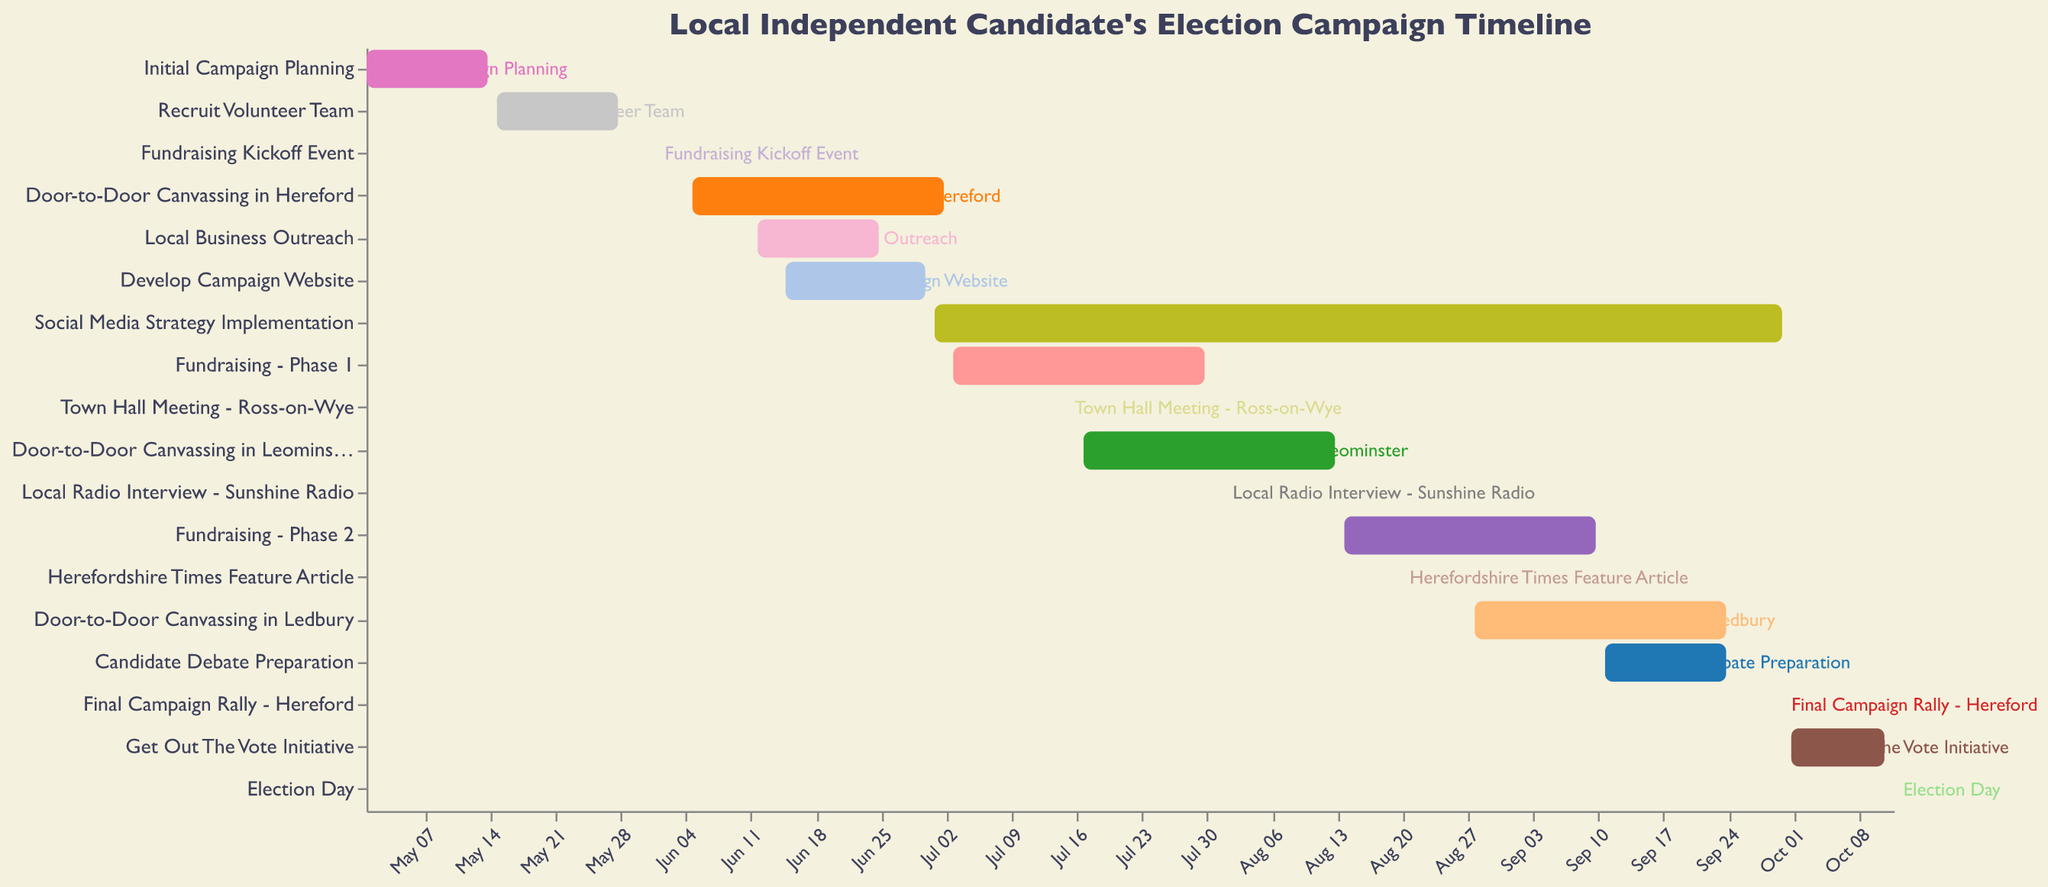What is the title of the Gantt Chart? The title is displayed at the top of the chart and reads "Local Independent Candidate's Election Campaign Timeline."
Answer: Local Independent Candidate's Election Campaign Timeline When does the "Initial Campaign Planning" phase begin and end? The phase is represented by a horizontal bar on the Gantt chart, starting on May 1 and ending on May 14.
Answer: May 1 to May 14 How long does the "Door-to-Door Canvassing in Hereford" phase last? The phase starts on June 5 and ends on July 2. The total duration is the difference between the two dates, which is 27 days.
Answer: 27 days Which campaign activity ends on the same day it starts? There are two tasks that start and end on the same day: "Fundraising Kickoff Event" on June 1 and "Local Radio Interview - Sunshine Radio" on August 1.
Answer: Fundraising Kickoff Event and Local Radio Interview - Sunshine Radio Which activity has the longest duration? The "Social Media Strategy Implementation" phase runs from July 1 to September 30, lasting 92 days, which is longer than any other activity.
Answer: Social Media Strategy Implementation Which activities are scheduled to be active during the entire month of August? By examining the Gantt chart for August, the activities include "Door-to-Door Canvassing in Leominster" (July 17 - August 13), "Local Radio Interview - Sunshine Radio" (August 1), "Fundraising - Phase 2" (August 14 - September 10), "Herefordshire Times Feature Article" (August 20), and "Door-to-Door Canvassing in Ledbury" (August 28 - September 24).
Answer: Fundraising - Phase 2 and Door-to-Door Canvassing in Ledbury Which activities overlap with "Candidate Debate Preparation"? "Candidate Debate Preparation" runs from September 11 to September 24. The overlapping activities are "Social Media Strategy Implementation" (July 1 - September 30) and "Door-to-Door Canvassing in Ledbury" (August 28 - September 24).
Answer: Social Media Strategy Implementation and Door-to-Door Canvassing in Ledbury How many fundraising phases are there and when do they occur? There are two fundraising phases: "Fundraising - Phase 1" (July 3 to July 30) and "Fundraising - Phase 2" (August 14 to September 10).
Answer: Two phases: July 3 to July 30 and August 14 to September 10 What comes right after the "Recruit Volunteer Team" phase? The "Recruit Volunteer Team" phase ends on May 28, and the next activity, according to the timeline, is the "Fundraising Kickoff Event" which starts on June 1.
Answer: Fundraising Kickoff Event When is the final campaign rally scheduled? The final campaign rally in Hereford is scheduled for September 30, as indicated by a horizontal bar ending on that date.
Answer: September 30 